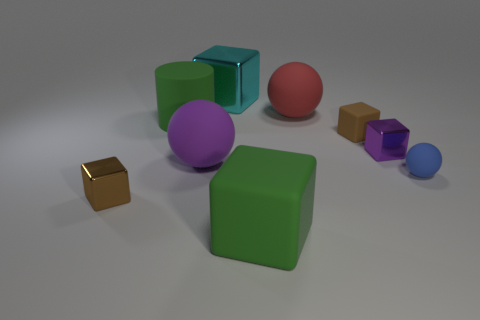How does the arrangement of shapes contribute to the composition of the image? The arrangement of the shapes in the image creates a balanced yet dynamic composition. The largest shapes, the green cube and the purple sphere, anchor the scene, while smaller shapes such as the gold cube, the red sphere, and the smaller cubes and sphere add complexity and depth, guiding the eye across the image and providing contrast in both size and placement. 